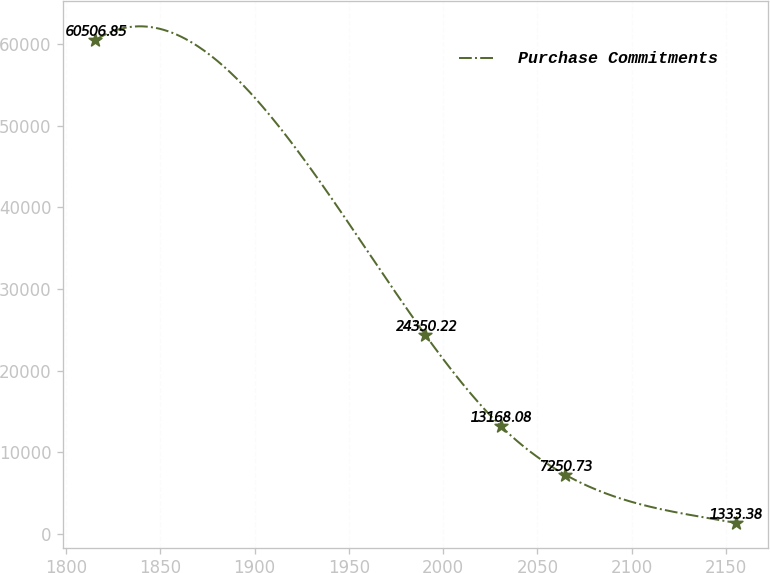<chart> <loc_0><loc_0><loc_500><loc_500><line_chart><ecel><fcel>Purchase Commitments<nl><fcel>1815.59<fcel>60506.8<nl><fcel>1990.63<fcel>24350.2<nl><fcel>2030.7<fcel>13168.1<nl><fcel>2064.65<fcel>7250.73<nl><fcel>2155.13<fcel>1333.38<nl></chart> 